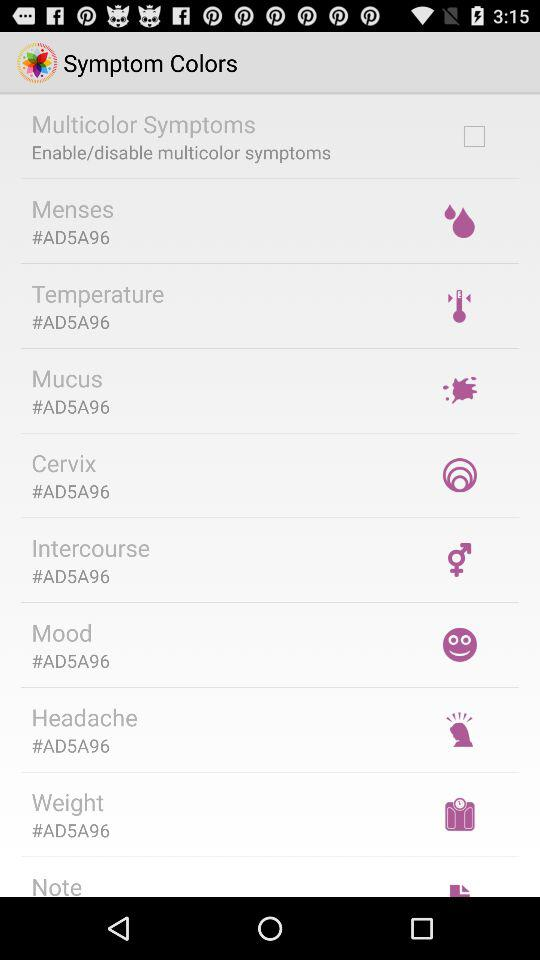The code #AD5A96 of which color?
When the provided information is insufficient, respond with <no answer>. <no answer> 